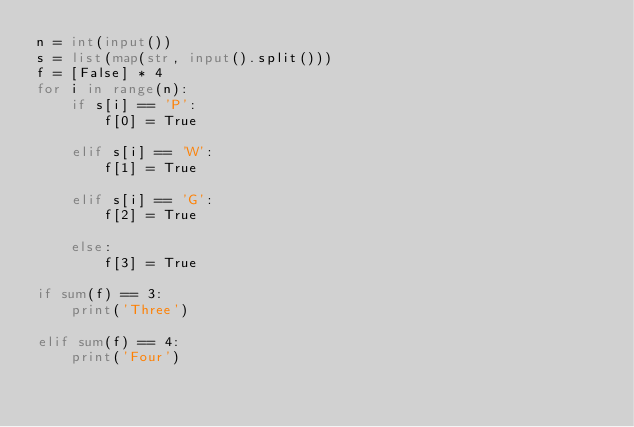<code> <loc_0><loc_0><loc_500><loc_500><_Python_>n = int(input())
s = list(map(str, input().split()))
f = [False] * 4
for i in range(n):
    if s[i] == 'P':
        f[0] = True

    elif s[i] == 'W':
        f[1] = True
    
    elif s[i] == 'G':
        f[2] = True
    
    else:
        f[3] = True

if sum(f) == 3:
    print('Three')

elif sum(f) == 4:
    print('Four')</code> 